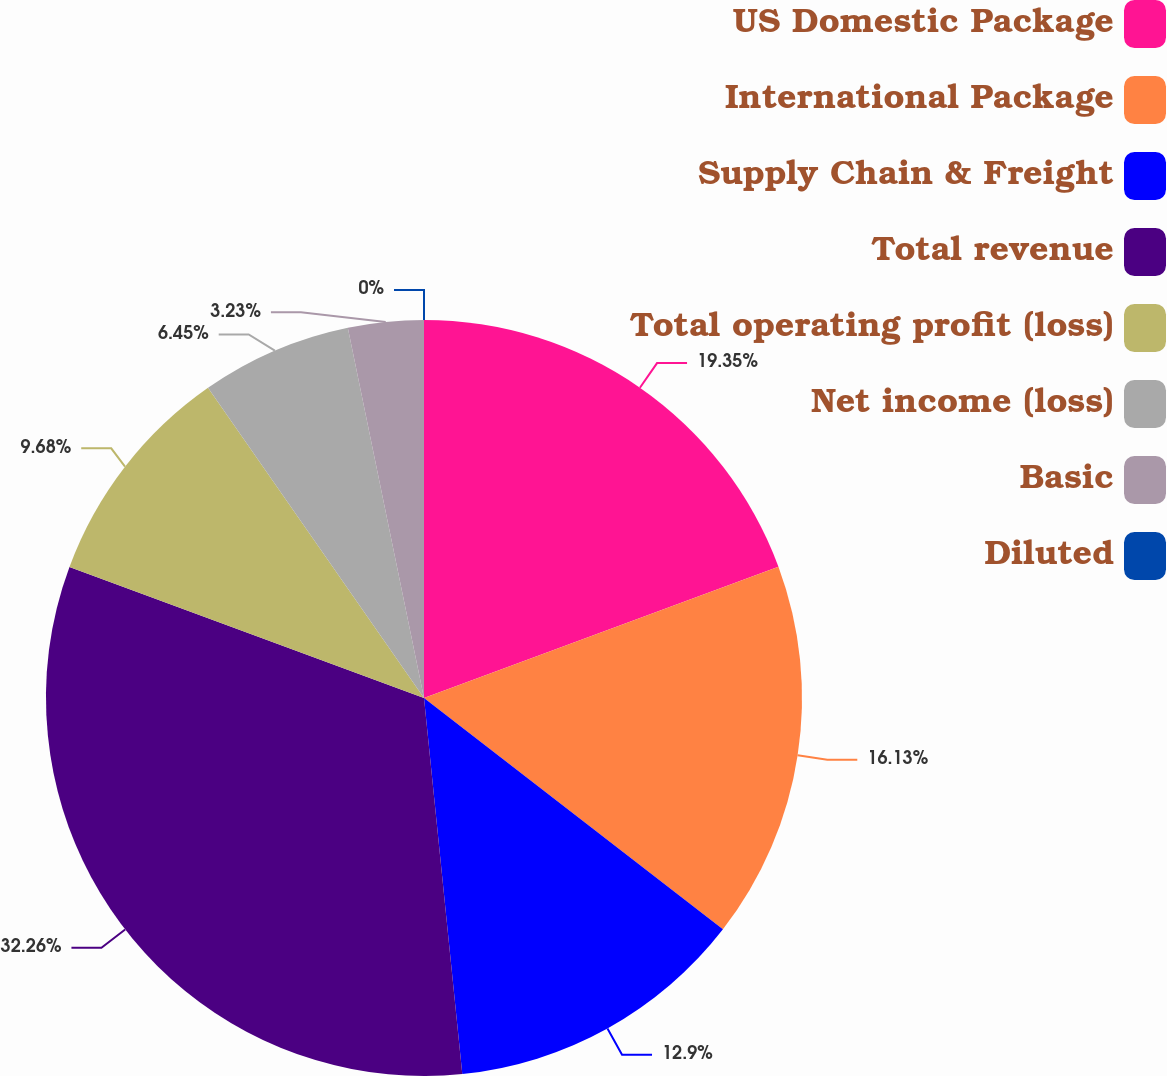Convert chart. <chart><loc_0><loc_0><loc_500><loc_500><pie_chart><fcel>US Domestic Package<fcel>International Package<fcel>Supply Chain & Freight<fcel>Total revenue<fcel>Total operating profit (loss)<fcel>Net income (loss)<fcel>Basic<fcel>Diluted<nl><fcel>19.35%<fcel>16.13%<fcel>12.9%<fcel>32.25%<fcel>9.68%<fcel>6.45%<fcel>3.23%<fcel>0.0%<nl></chart> 